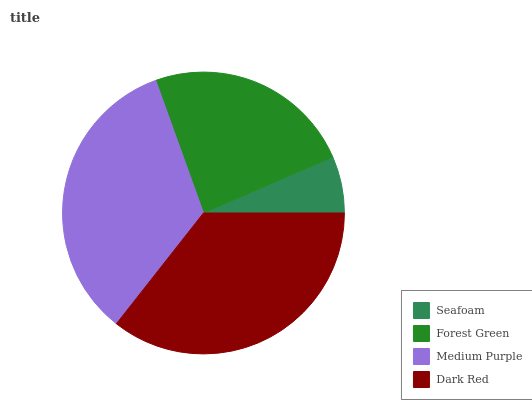Is Seafoam the minimum?
Answer yes or no. Yes. Is Dark Red the maximum?
Answer yes or no. Yes. Is Forest Green the minimum?
Answer yes or no. No. Is Forest Green the maximum?
Answer yes or no. No. Is Forest Green greater than Seafoam?
Answer yes or no. Yes. Is Seafoam less than Forest Green?
Answer yes or no. Yes. Is Seafoam greater than Forest Green?
Answer yes or no. No. Is Forest Green less than Seafoam?
Answer yes or no. No. Is Medium Purple the high median?
Answer yes or no. Yes. Is Forest Green the low median?
Answer yes or no. Yes. Is Dark Red the high median?
Answer yes or no. No. Is Seafoam the low median?
Answer yes or no. No. 